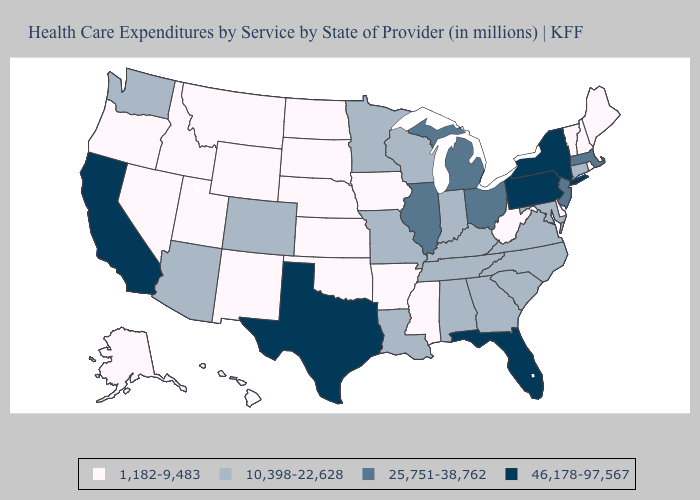What is the value of Alabama?
Concise answer only. 10,398-22,628. What is the lowest value in states that border Wyoming?
Concise answer only. 1,182-9,483. Is the legend a continuous bar?
Write a very short answer. No. What is the highest value in the USA?
Give a very brief answer. 46,178-97,567. Name the states that have a value in the range 46,178-97,567?
Be succinct. California, Florida, New York, Pennsylvania, Texas. How many symbols are there in the legend?
Concise answer only. 4. Which states have the highest value in the USA?
Give a very brief answer. California, Florida, New York, Pennsylvania, Texas. What is the value of West Virginia?
Give a very brief answer. 1,182-9,483. What is the lowest value in the Northeast?
Answer briefly. 1,182-9,483. Which states hav the highest value in the West?
Keep it brief. California. Among the states that border Montana , which have the highest value?
Concise answer only. Idaho, North Dakota, South Dakota, Wyoming. What is the highest value in the USA?
Concise answer only. 46,178-97,567. Does New York have the highest value in the USA?
Answer briefly. Yes. Does Delaware have the highest value in the South?
Answer briefly. No. What is the value of Texas?
Answer briefly. 46,178-97,567. 